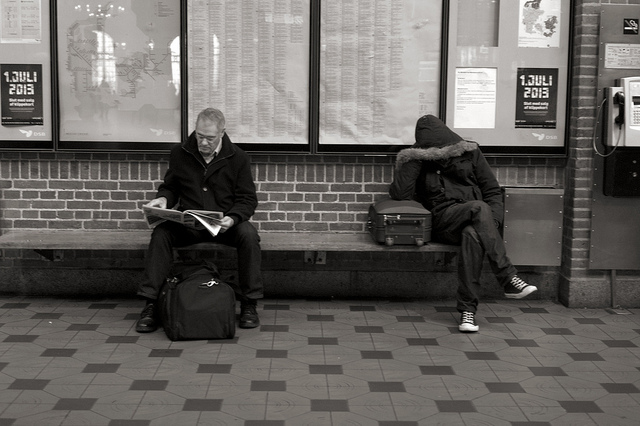<image>What is running down the side of the building on the left side behind the bench? I don't know what is running down the side of the building on the left side behind the bench. It could be bricks, a sign, a window, or nothing at all. What is running down the side of the building on the left side behind the bench? I don't know what is running down the side of the building on the left side behind the bench. It can be bricks, a sign, or nothing at all. 